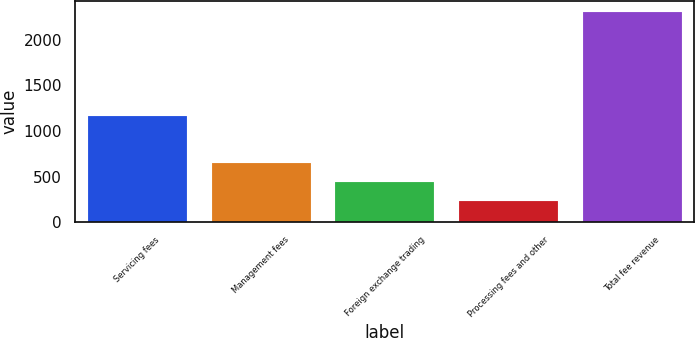Convert chart. <chart><loc_0><loc_0><loc_500><loc_500><bar_chart><fcel>Servicing fees<fcel>Management fees<fcel>Foreign exchange trading<fcel>Processing fees and other<fcel>Total fee revenue<nl><fcel>1170<fcel>651.2<fcel>443.6<fcel>236<fcel>2312<nl></chart> 